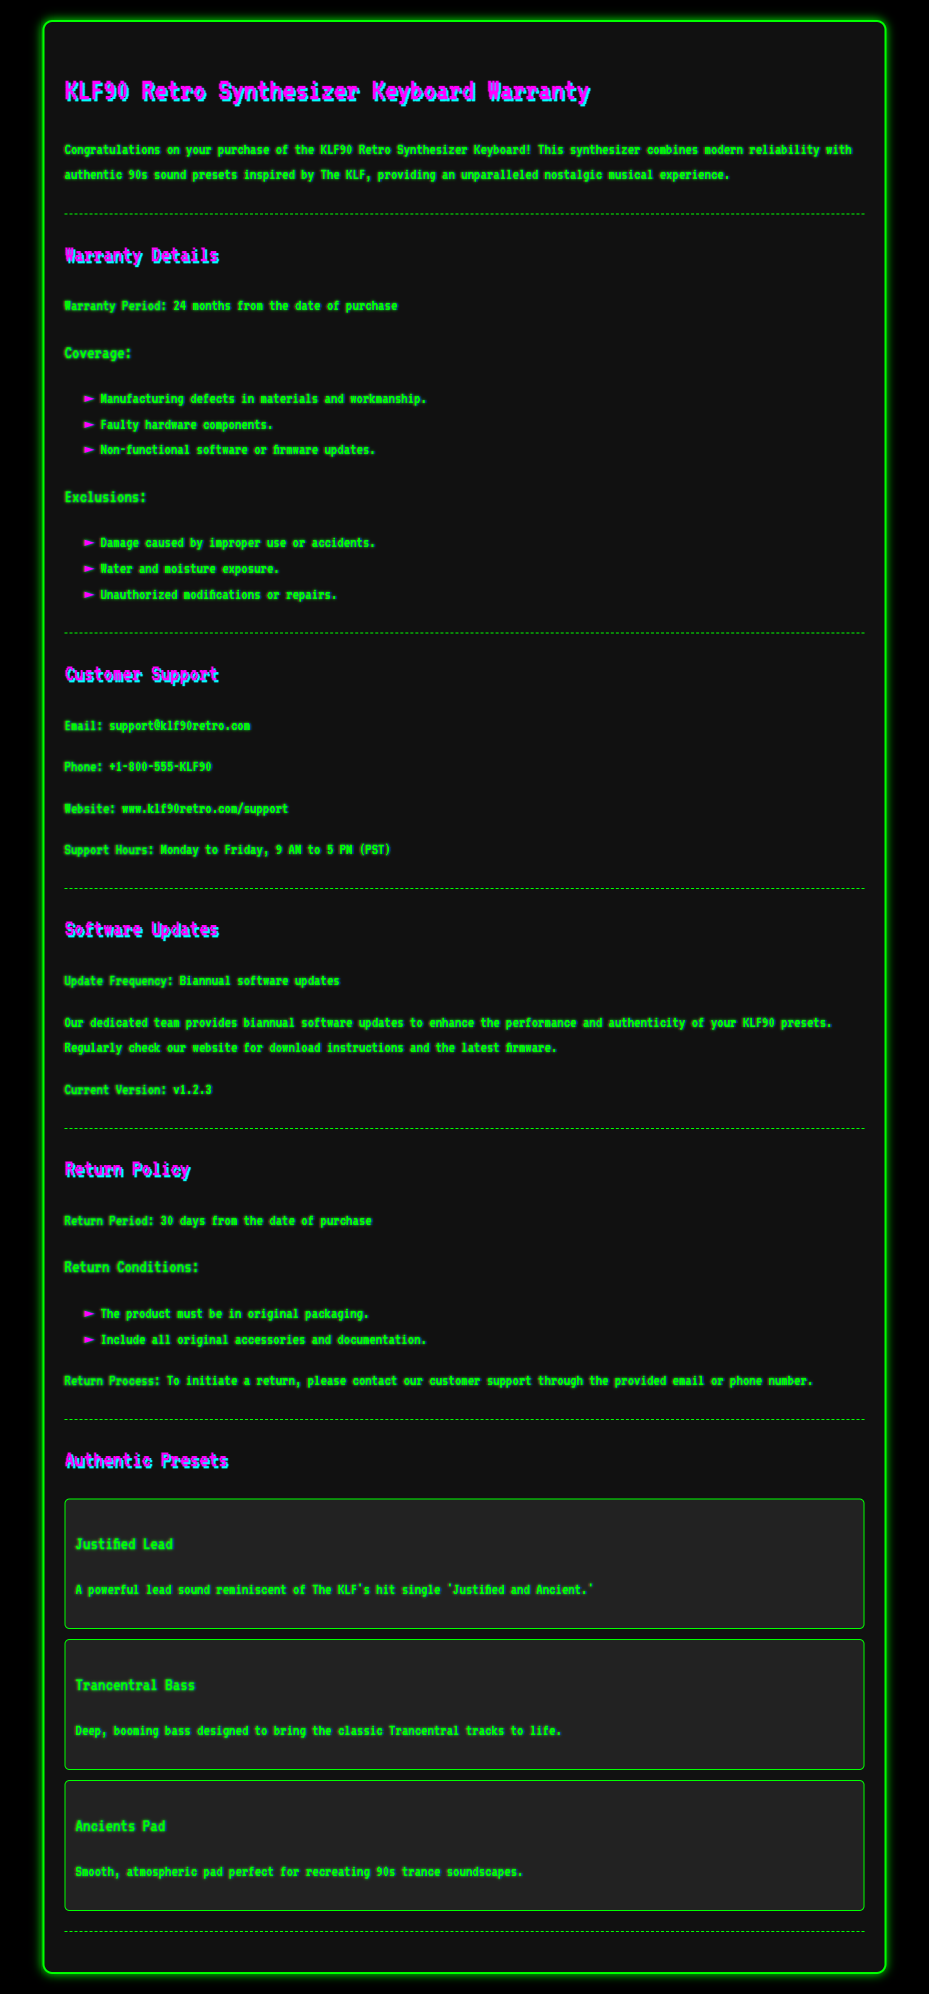What is the warranty period? The warranty period is mentioned in the document as 24 months from the date of purchase.
Answer: 24 months What are the customer support hours? The customer support hours are stated in the document as Monday to Friday, 9 AM to 5 PM (PST).
Answer: 9 AM to 5 PM (PST) What is the current software version? The document specifies the current software version as v1.2.3.
Answer: v1.2.3 Which hardware component is covered under the warranty? The document lists faulty hardware components among the warranty coverage areas.
Answer: Faulty hardware components What must be included in a return? The return conditions specify that all original accessories and documentation must be included in a return.
Answer: Original accessories and documentation What is excluded from the warranty? The document states that damage caused by improper use or accidents is excluded from the warranty.
Answer: Improper use or accidents How often are software updates provided? The frequency of software updates, according to the document, is biannual.
Answer: Biannual What is the return period? The return period is stated in the document as 30 days from the date of purchase.
Answer: 30 days What is the email for customer support? The document provides the email for customer support as support@klf90retro.com.
Answer: support@klf90retro.com 